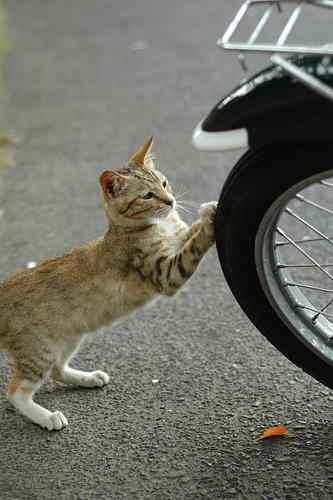What could potentially puncture the tire? claws 